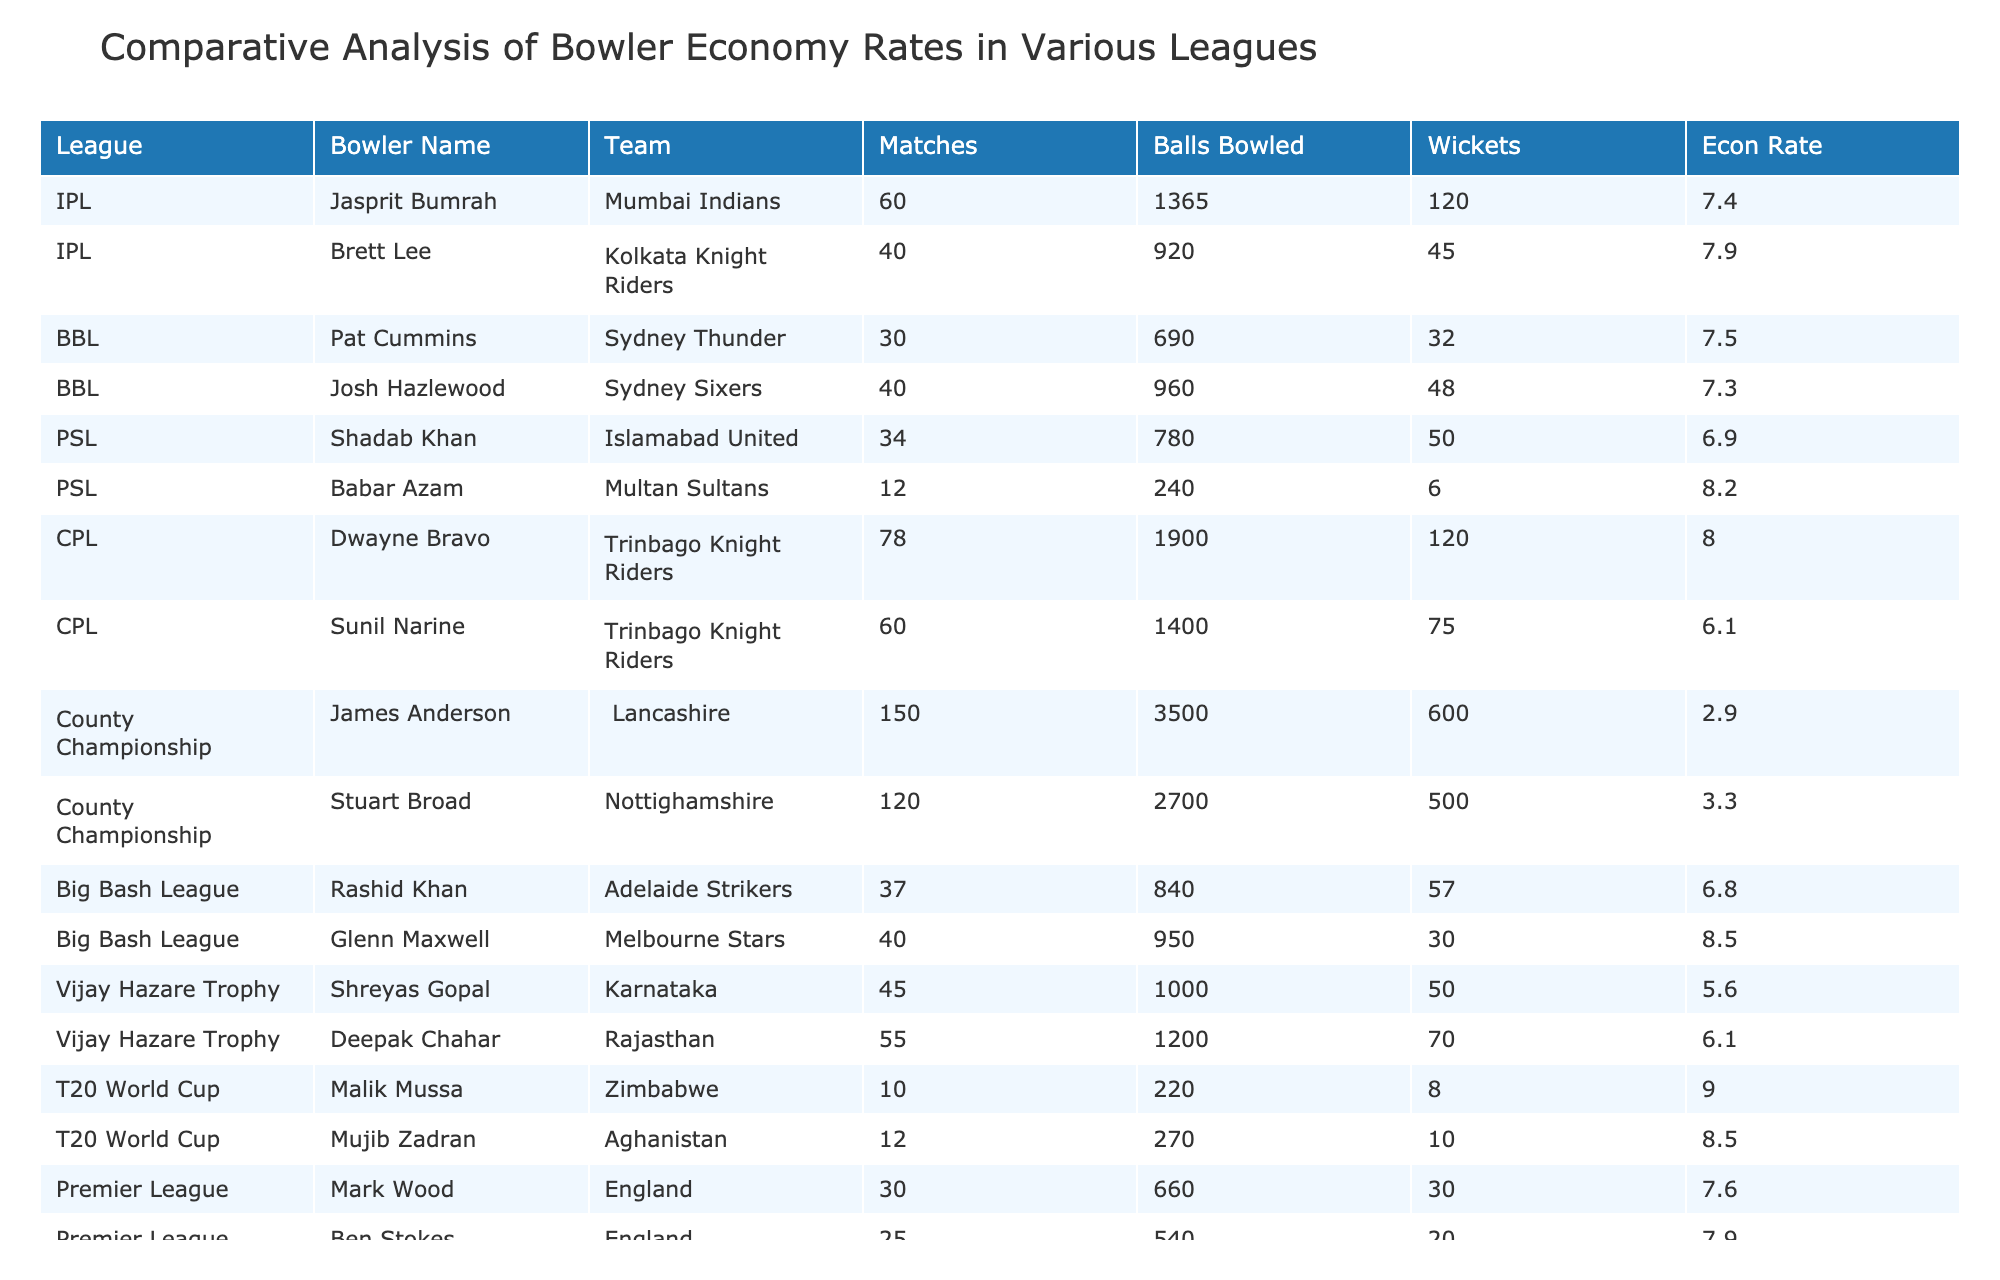What is the economy rate of Jasprit Bumrah? The table lists Jasprit Bumrah's economy rate directly as 7.4.
Answer: 7.4 Which bowler has the lowest economy rate in the table? By checking the "Econ Rate" column, I find that Sunil Narine has the lowest economy rate at 6.1.
Answer: 6.1 How many matches did Mark Wood play? The table shows Mark Wood played 30 matches.
Answer: 30 What is the total number of wickets taken by bowlers in the IPL? Adding up the wickets for IPL bowlers (120 + 45 = 165) gives a total of 165 wickets.
Answer: 165 Is Babar Azam's economy rate higher than that of Shadab Khan? Yes, Babar Azam's economy rate is 8.2, which is higher than Shadab Khan's 6.9.
Answer: Yes What is the average economy rate of bowlers in the PSL? The economy rates for PSL bowlers are 6.9 and 8.2. The average is (6.9 + 8.2) / 2 = 7.55.
Answer: 7.55 Which league has the highest overall economy rate based on the listed bowlers? The highest individual economy rate is associated with Malik Mussa at 9.0 in the T20 World Cup, indicating that it could have the highest overall economy for the listed bowlers.
Answer: T20 World Cup Can you identify how many bowlers have an economy rate below 7.0? By reviewing the table, I find that only Shadab Khan and Sunil Narine have economy rates below 7.0, making it 2 bowlers.
Answer: 2 What is the combined number of wickets taken by bowlers within the County Championship? For the County Championship, James Anderson has 600 wickets and Stuart Broad has 500 wickets. Combining these gives 600 + 500 = 1100 wickets total.
Answer: 1100 In which league did the bowler with the most matches play? The bowler with the most matches is James Anderson with 150 matches in the County Championship.
Answer: County Championship 